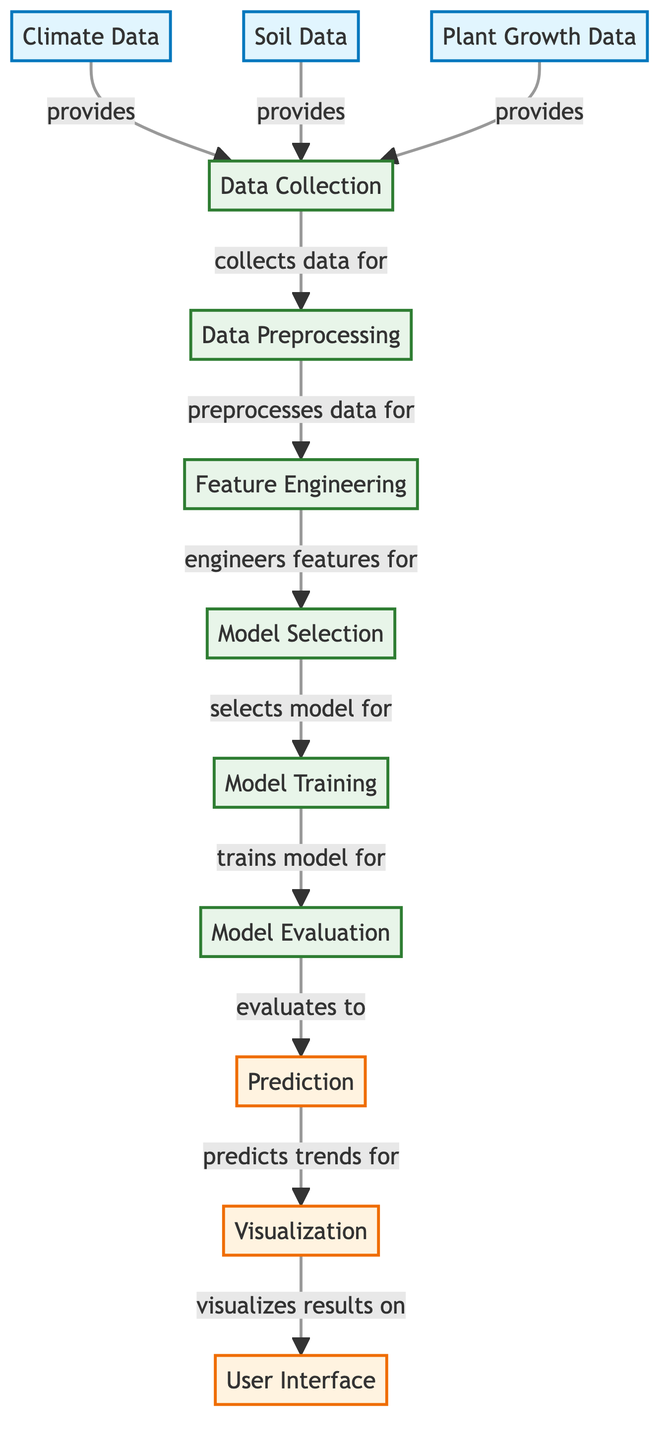What type of data is sourced for this analysis? The diagram shows three types of source data: Climate Data, Soil Data, and Plant Growth Data, which all provide information for the Data Collection process.
Answer: Climate Data, Soil Data, Plant Growth Data How many processes are involved in this machine learning analysis? The diagram contains five distinct process nodes labeled as Data Collection, Data Preprocessing, Feature Engineering, Model Selection, and Model Training.
Answer: Five What is the output after Model Evaluation? The Model Evaluation process leads to the Prediction node, which indicates the output generated after evaluating the model.
Answer: Prediction Which nodes are directly linked to the Data Collection node? The Data Collection node receives data from three sources: Climate Data, Soil Data, and Plant Growth Data, which are directly connected to it.
Answer: Climate Data, Soil Data, Plant Growth Data What is the sequence of steps from data input to visualization? The diagram outlines a flow starting from Data Collection, going through Preprocessing, Feature Engineering, Model Selection, Model Training, Model Evaluation, Prediction, and finally, Visualization.
Answer: Data Collection, Data Preprocessing, Feature Engineering, Model Selection, Model Training, Model Evaluation, Prediction, Visualization What type of information does the Visualization node provide? The Visualization node displays the trends predicted by the analysis, serving as a way to present the results to the user in a comprehensible format.
Answer: Results visualization Which process follows Feature Engineering? After the Feature Engineering process, the next step is Model Selection, indicating the transition from preparing data to choosing an appropriate machine learning model.
Answer: Model Selection What is the primary function of the Model Training process? The primary function of Model Training is to train the selected model based on the processed data, allowing it to learn patterns and relationships.
Answer: Train the model How many data sources contribute to the Data Collection process? There are three data sources (Climate Data, Soil Data, Plant Growth Data) that contribute information for the Data Collection step in the diagram.
Answer: Three 